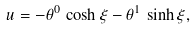<formula> <loc_0><loc_0><loc_500><loc_500>u = - \theta ^ { 0 } \, \cosh \xi - \theta ^ { 1 } \, \sinh \xi ,</formula> 